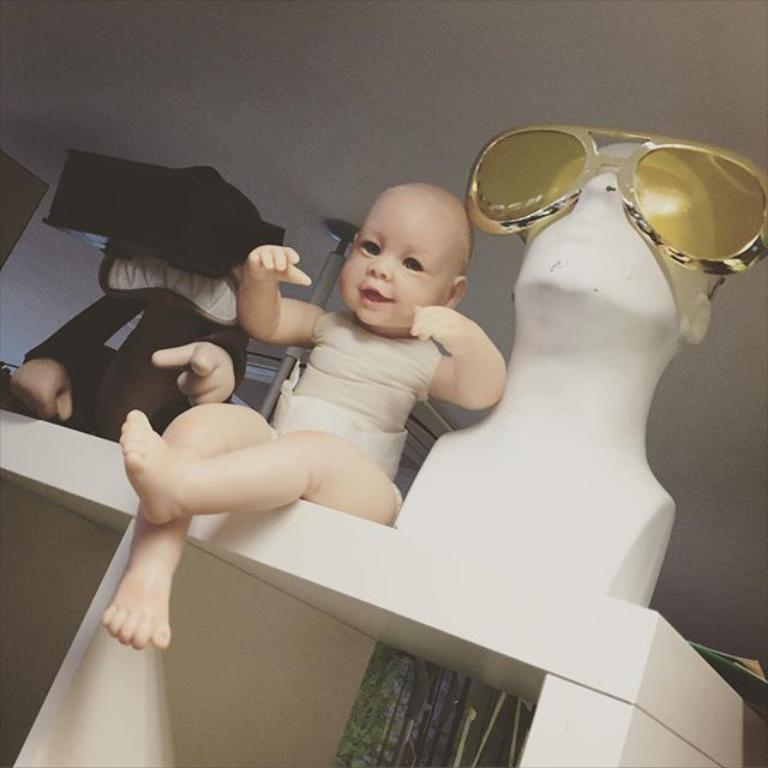Who is present in the image? There is a person (you) and a baby in the image. What else can be seen in the image besides the people? There is a mannequin with glasses, a table, a wall, and a rod in the image. What is the purpose of the bean in the image? There is no bean present in the image, so it is not possible to determine its purpose. 